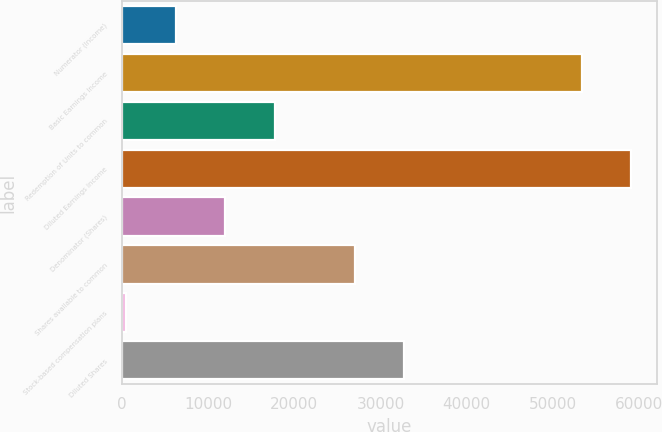Convert chart to OTSL. <chart><loc_0><loc_0><loc_500><loc_500><bar_chart><fcel>Numerator (Income)<fcel>Basic Earnings Income<fcel>Redemption of Units to common<fcel>Diluted Earnings Income<fcel>Denominator (Shares)<fcel>Shares available to common<fcel>Stock-based compensation plans<fcel>Diluted Shares<nl><fcel>6273.1<fcel>53343<fcel>17755.3<fcel>59084.1<fcel>12014.2<fcel>26993<fcel>532<fcel>32734.1<nl></chart> 